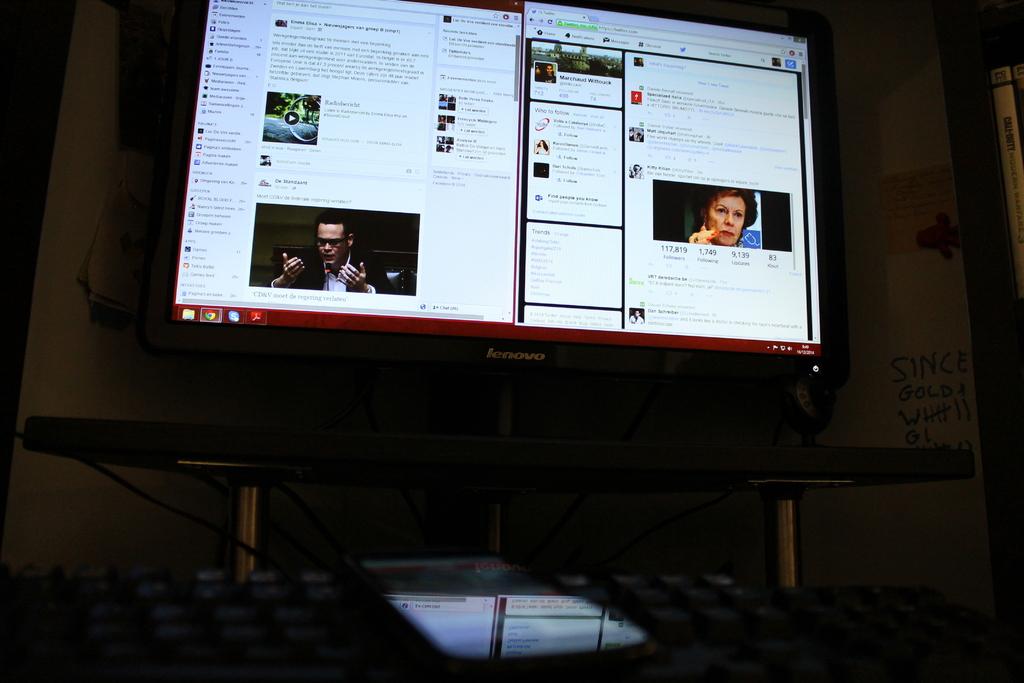What's the name of this monitor?
Make the answer very short. Lenovo. What is the first word written on the wall on the right?
Give a very brief answer. Since. 